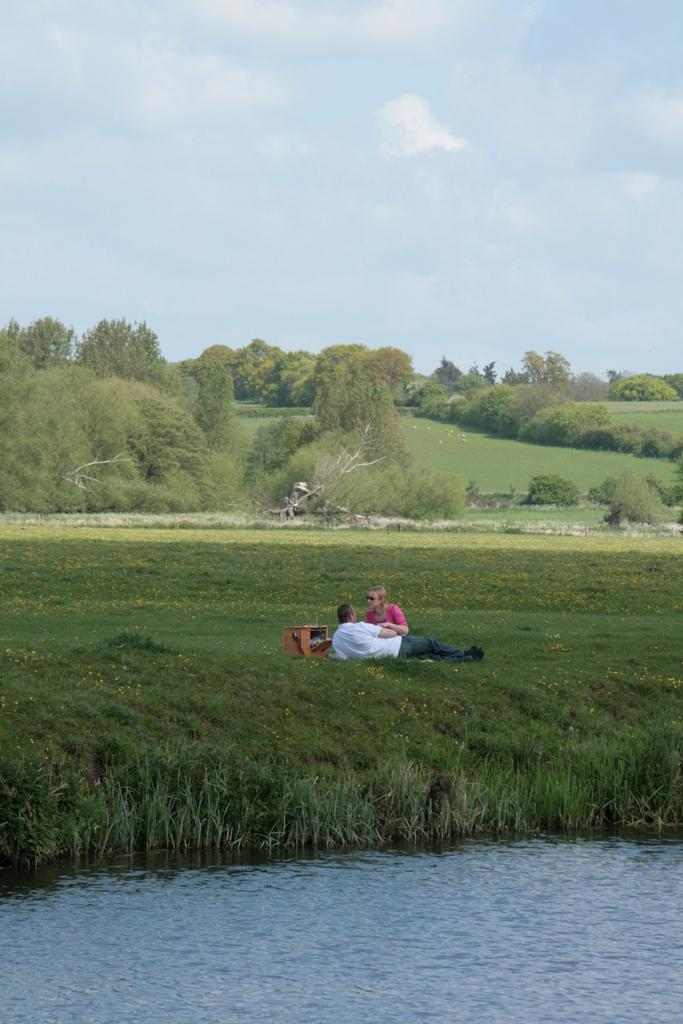What is present at the bottom of the image? There is water and grass at the bottom of the image. How many people are in the image? There are two persons in the image. What can be seen in the background of the image? There are trees in the background of the image. What is visible at the top of the image? The sky is visible at the top of the image. Can you tell if the image was taken during the day or night? The image was likely taken during the day. What might be the location of the image? The image may have been taken near a lake. What type of canvas is being used by the person in the image? There is no canvas present in the image, and no person is depicted using one. What thoughts are the trees in the background having in the image? Trees do not have thoughts, so this question cannot be answered. 